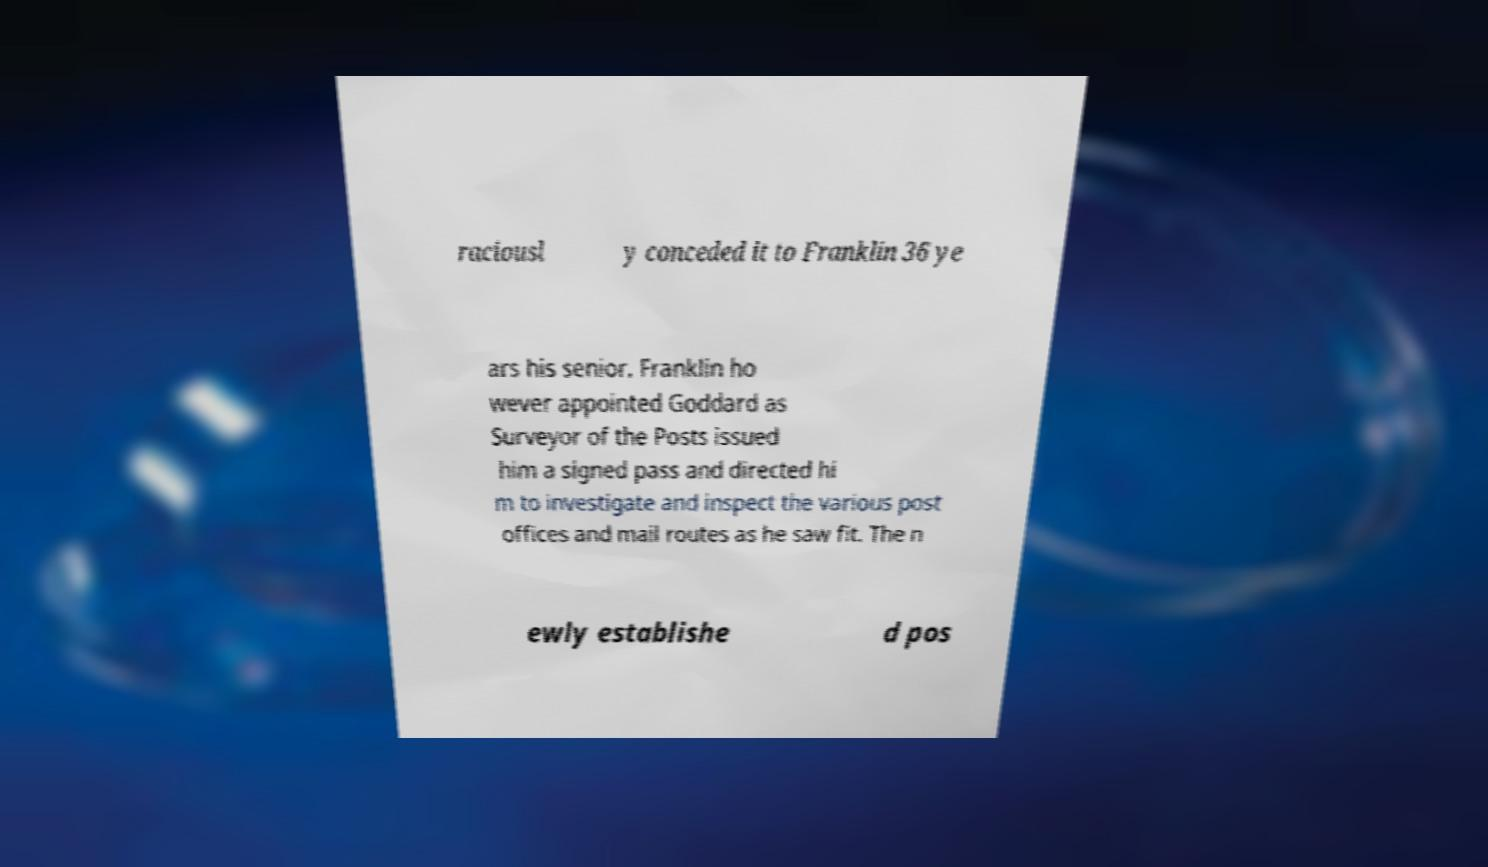There's text embedded in this image that I need extracted. Can you transcribe it verbatim? raciousl y conceded it to Franklin 36 ye ars his senior. Franklin ho wever appointed Goddard as Surveyor of the Posts issued him a signed pass and directed hi m to investigate and inspect the various post offices and mail routes as he saw fit. The n ewly establishe d pos 